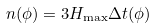Convert formula to latex. <formula><loc_0><loc_0><loc_500><loc_500>n ( \phi ) = 3 H _ { \max } \Delta t ( \phi )</formula> 